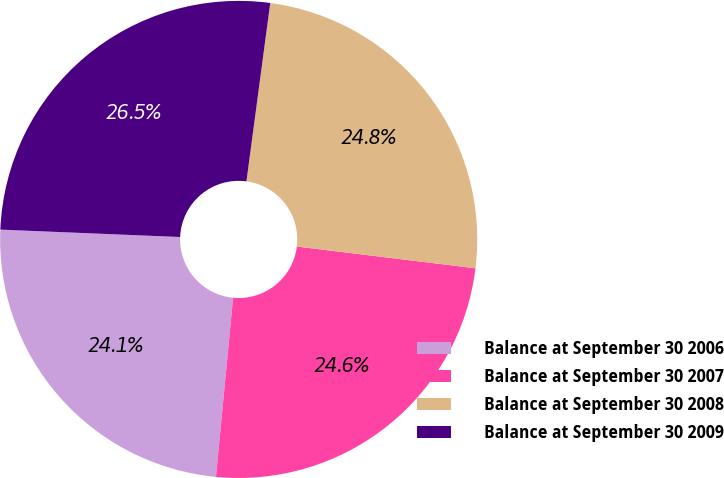Convert chart. <chart><loc_0><loc_0><loc_500><loc_500><pie_chart><fcel>Balance at September 30 2006<fcel>Balance at September 30 2007<fcel>Balance at September 30 2008<fcel>Balance at September 30 2009<nl><fcel>24.14%<fcel>24.59%<fcel>24.82%<fcel>26.46%<nl></chart> 